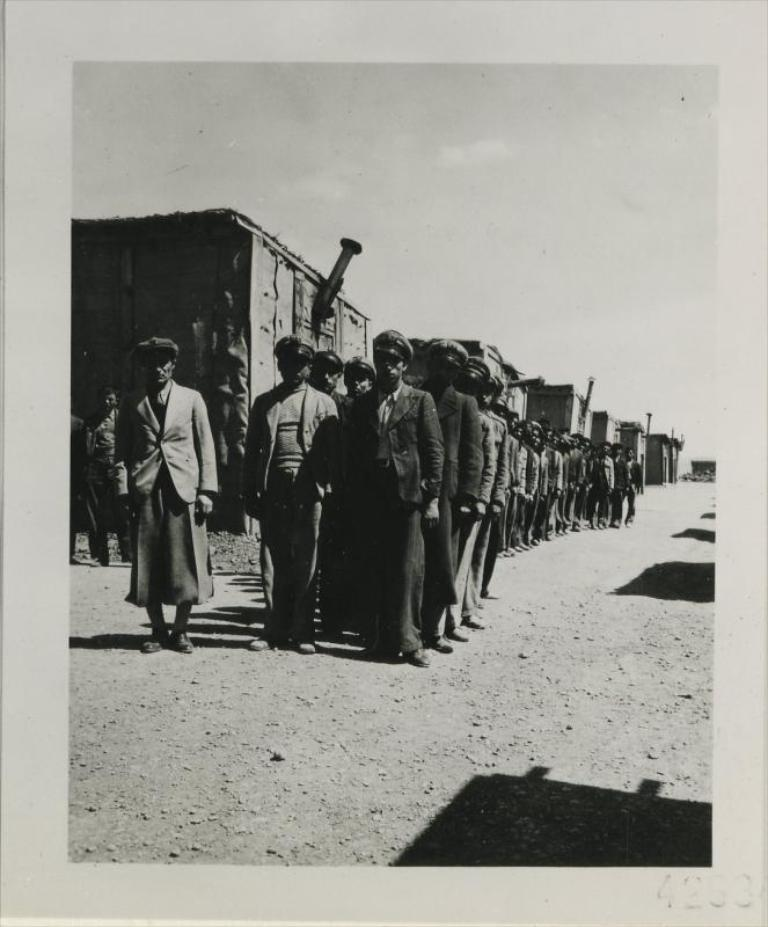What is the color scheme of the image? The image is black and white. What can be seen in the foreground of the image? There is a group of people standing on a path. What is located behind the people in the image? There are containers visible behind the people. What is visible in the background of the image? The sky is visible in the image. What type of comfort can be seen being provided by the people in the image? There is no indication of comfort being provided in the image, as it only shows a group of people standing on a path with containers behind them. What type of writing can be seen on the containers in the image? There is no writing visible on the containers in the image; they are simply containers. 